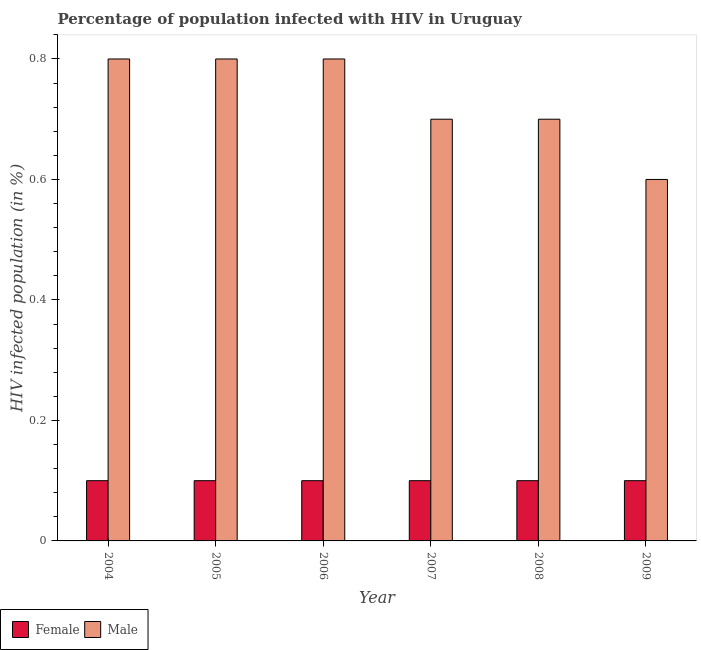How many groups of bars are there?
Make the answer very short. 6. Are the number of bars per tick equal to the number of legend labels?
Make the answer very short. Yes. Are the number of bars on each tick of the X-axis equal?
Your answer should be very brief. Yes. How many bars are there on the 5th tick from the left?
Your response must be concise. 2. What is the label of the 3rd group of bars from the left?
Offer a terse response. 2006. What is the percentage of females who are infected with hiv in 2004?
Make the answer very short. 0.1. Across all years, what is the maximum percentage of males who are infected with hiv?
Offer a terse response. 0.8. In which year was the percentage of females who are infected with hiv maximum?
Offer a terse response. 2004. What is the average percentage of males who are infected with hiv per year?
Offer a terse response. 0.73. In the year 2004, what is the difference between the percentage of males who are infected with hiv and percentage of females who are infected with hiv?
Your response must be concise. 0. In how many years, is the percentage of males who are infected with hiv greater than 0.2 %?
Your answer should be compact. 6. What is the ratio of the percentage of females who are infected with hiv in 2004 to that in 2009?
Your response must be concise. 1. What is the difference between the highest and the second highest percentage of females who are infected with hiv?
Provide a short and direct response. 0. What is the difference between the highest and the lowest percentage of males who are infected with hiv?
Your answer should be compact. 0.2. In how many years, is the percentage of males who are infected with hiv greater than the average percentage of males who are infected with hiv taken over all years?
Make the answer very short. 3. Is the sum of the percentage of females who are infected with hiv in 2004 and 2005 greater than the maximum percentage of males who are infected with hiv across all years?
Keep it short and to the point. Yes. What does the 2nd bar from the right in 2006 represents?
Your answer should be very brief. Female. Are all the bars in the graph horizontal?
Ensure brevity in your answer.  No. What is the difference between two consecutive major ticks on the Y-axis?
Your answer should be compact. 0.2. Are the values on the major ticks of Y-axis written in scientific E-notation?
Provide a succinct answer. No. Does the graph contain any zero values?
Keep it short and to the point. No. Where does the legend appear in the graph?
Keep it short and to the point. Bottom left. How many legend labels are there?
Ensure brevity in your answer.  2. How are the legend labels stacked?
Give a very brief answer. Horizontal. What is the title of the graph?
Your response must be concise. Percentage of population infected with HIV in Uruguay. Does "Adolescent fertility rate" appear as one of the legend labels in the graph?
Ensure brevity in your answer.  No. What is the label or title of the X-axis?
Your answer should be compact. Year. What is the label or title of the Y-axis?
Your answer should be compact. HIV infected population (in %). What is the HIV infected population (in %) in Male in 2004?
Make the answer very short. 0.8. What is the HIV infected population (in %) of Female in 2006?
Give a very brief answer. 0.1. What is the HIV infected population (in %) in Male in 2007?
Provide a short and direct response. 0.7. What is the HIV infected population (in %) of Female in 2008?
Your answer should be compact. 0.1. What is the HIV infected population (in %) in Male in 2009?
Provide a succinct answer. 0.6. Across all years, what is the maximum HIV infected population (in %) of Female?
Provide a short and direct response. 0.1. Across all years, what is the maximum HIV infected population (in %) in Male?
Your answer should be compact. 0.8. What is the difference between the HIV infected population (in %) in Female in 2004 and that in 2005?
Offer a very short reply. 0. What is the difference between the HIV infected population (in %) of Male in 2004 and that in 2005?
Provide a succinct answer. 0. What is the difference between the HIV infected population (in %) in Female in 2004 and that in 2006?
Offer a very short reply. 0. What is the difference between the HIV infected population (in %) of Female in 2004 and that in 2007?
Provide a short and direct response. 0. What is the difference between the HIV infected population (in %) in Male in 2004 and that in 2007?
Your answer should be compact. 0.1. What is the difference between the HIV infected population (in %) in Female in 2004 and that in 2009?
Provide a succinct answer. 0. What is the difference between the HIV infected population (in %) of Male in 2004 and that in 2009?
Make the answer very short. 0.2. What is the difference between the HIV infected population (in %) of Female in 2005 and that in 2006?
Your answer should be compact. 0. What is the difference between the HIV infected population (in %) of Male in 2005 and that in 2006?
Your answer should be very brief. 0. What is the difference between the HIV infected population (in %) in Female in 2005 and that in 2007?
Your answer should be compact. 0. What is the difference between the HIV infected population (in %) in Male in 2005 and that in 2007?
Give a very brief answer. 0.1. What is the difference between the HIV infected population (in %) of Male in 2005 and that in 2008?
Provide a short and direct response. 0.1. What is the difference between the HIV infected population (in %) in Female in 2005 and that in 2009?
Ensure brevity in your answer.  0. What is the difference between the HIV infected population (in %) of Male in 2005 and that in 2009?
Keep it short and to the point. 0.2. What is the difference between the HIV infected population (in %) of Female in 2006 and that in 2007?
Your answer should be compact. 0. What is the difference between the HIV infected population (in %) in Male in 2006 and that in 2007?
Your answer should be compact. 0.1. What is the difference between the HIV infected population (in %) of Male in 2007 and that in 2008?
Keep it short and to the point. 0. What is the difference between the HIV infected population (in %) in Female in 2004 and the HIV infected population (in %) in Male in 2006?
Your response must be concise. -0.7. What is the difference between the HIV infected population (in %) in Female in 2004 and the HIV infected population (in %) in Male in 2008?
Offer a very short reply. -0.6. What is the difference between the HIV infected population (in %) in Female in 2004 and the HIV infected population (in %) in Male in 2009?
Your answer should be very brief. -0.5. What is the difference between the HIV infected population (in %) in Female in 2005 and the HIV infected population (in %) in Male in 2007?
Ensure brevity in your answer.  -0.6. What is the difference between the HIV infected population (in %) in Female in 2005 and the HIV infected population (in %) in Male in 2009?
Your response must be concise. -0.5. What is the difference between the HIV infected population (in %) of Female in 2006 and the HIV infected population (in %) of Male in 2007?
Your response must be concise. -0.6. What is the difference between the HIV infected population (in %) of Female in 2006 and the HIV infected population (in %) of Male in 2009?
Ensure brevity in your answer.  -0.5. What is the difference between the HIV infected population (in %) of Female in 2007 and the HIV infected population (in %) of Male in 2009?
Provide a short and direct response. -0.5. What is the average HIV infected population (in %) of Male per year?
Your answer should be very brief. 0.73. In the year 2006, what is the difference between the HIV infected population (in %) in Female and HIV infected population (in %) in Male?
Keep it short and to the point. -0.7. In the year 2009, what is the difference between the HIV infected population (in %) of Female and HIV infected population (in %) of Male?
Your answer should be very brief. -0.5. What is the ratio of the HIV infected population (in %) in Female in 2004 to that in 2005?
Your answer should be very brief. 1. What is the ratio of the HIV infected population (in %) in Male in 2004 to that in 2005?
Offer a very short reply. 1. What is the ratio of the HIV infected population (in %) in Male in 2004 to that in 2007?
Make the answer very short. 1.14. What is the ratio of the HIV infected population (in %) of Male in 2004 to that in 2008?
Your answer should be very brief. 1.14. What is the ratio of the HIV infected population (in %) of Female in 2005 to that in 2006?
Your response must be concise. 1. What is the ratio of the HIV infected population (in %) in Male in 2005 to that in 2006?
Your response must be concise. 1. What is the ratio of the HIV infected population (in %) of Female in 2006 to that in 2007?
Offer a very short reply. 1. What is the ratio of the HIV infected population (in %) of Male in 2006 to that in 2007?
Offer a very short reply. 1.14. What is the ratio of the HIV infected population (in %) in Male in 2006 to that in 2009?
Your answer should be compact. 1.33. What is the ratio of the HIV infected population (in %) in Male in 2007 to that in 2008?
Your answer should be very brief. 1. What is the ratio of the HIV infected population (in %) of Male in 2007 to that in 2009?
Your response must be concise. 1.17. What is the ratio of the HIV infected population (in %) in Male in 2008 to that in 2009?
Your answer should be very brief. 1.17. What is the difference between the highest and the second highest HIV infected population (in %) in Female?
Your response must be concise. 0. What is the difference between the highest and the lowest HIV infected population (in %) in Male?
Your answer should be very brief. 0.2. 